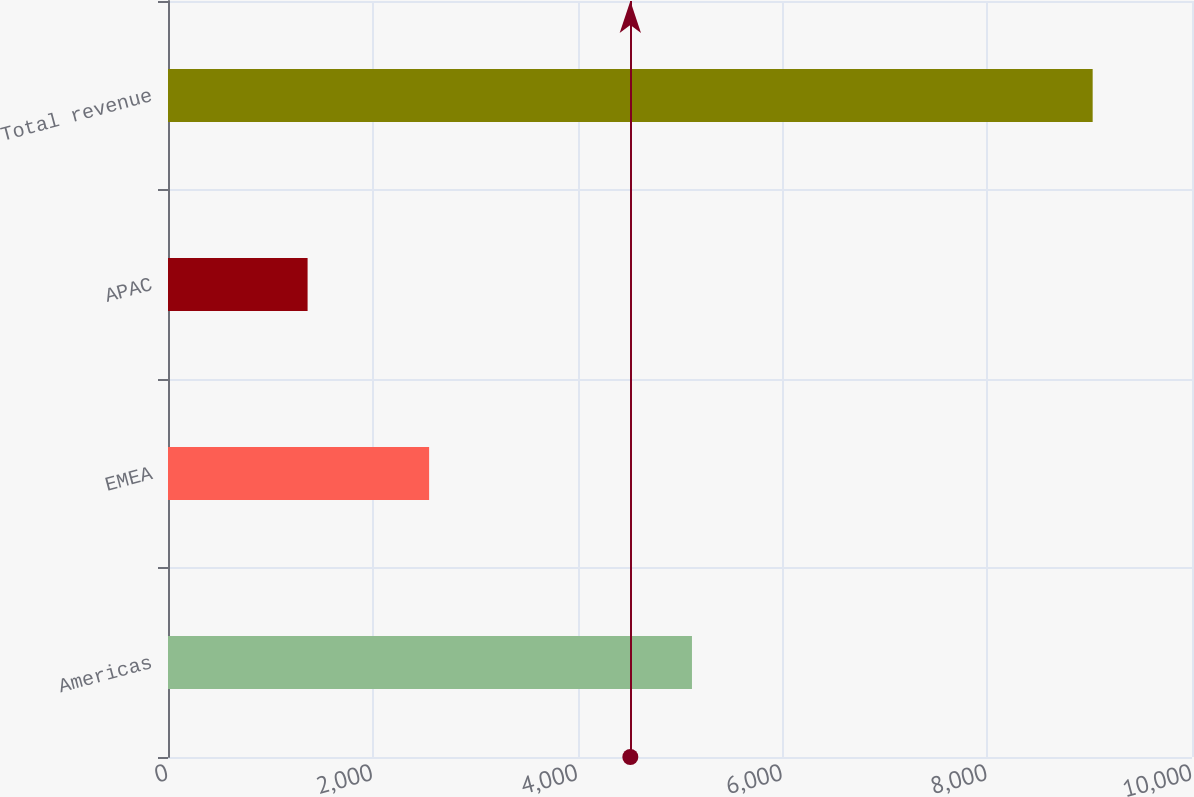<chart> <loc_0><loc_0><loc_500><loc_500><bar_chart><fcel>Americas<fcel>EMEA<fcel>APAC<fcel>Total revenue<nl><fcel>5116.8<fcel>2550<fcel>1363.2<fcel>9030<nl></chart> 